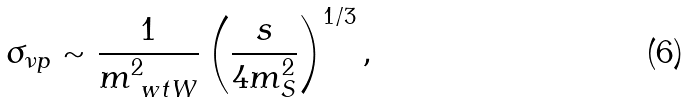<formula> <loc_0><loc_0><loc_500><loc_500>\sigma _ { \nu p } \sim \frac { 1 } { m _ { \ w t W } ^ { 2 } } \left ( \frac { s } { 4 m _ { S } ^ { 2 } } \right ) ^ { 1 / 3 } ,</formula> 